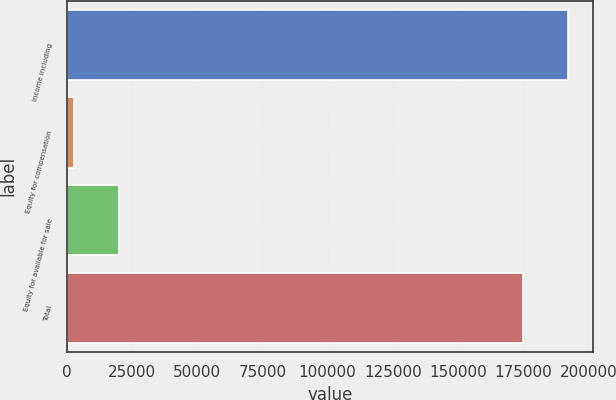Convert chart. <chart><loc_0><loc_0><loc_500><loc_500><bar_chart><fcel>Income including<fcel>Equity for compensation<fcel>Equity for available for sale<fcel>Total<nl><fcel>192217<fcel>2613<fcel>19917.3<fcel>174913<nl></chart> 